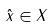<formula> <loc_0><loc_0><loc_500><loc_500>\hat { x } \in X</formula> 